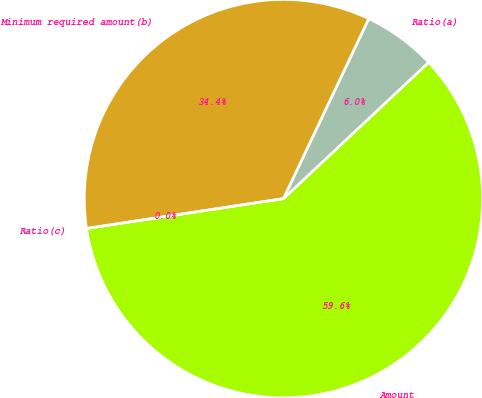Convert chart. <chart><loc_0><loc_0><loc_500><loc_500><pie_chart><fcel>Amount<fcel>Ratio(a)<fcel>Minimum required amount(b)<fcel>Ratio(c)<nl><fcel>59.6%<fcel>5.96%<fcel>34.44%<fcel>0.0%<nl></chart> 